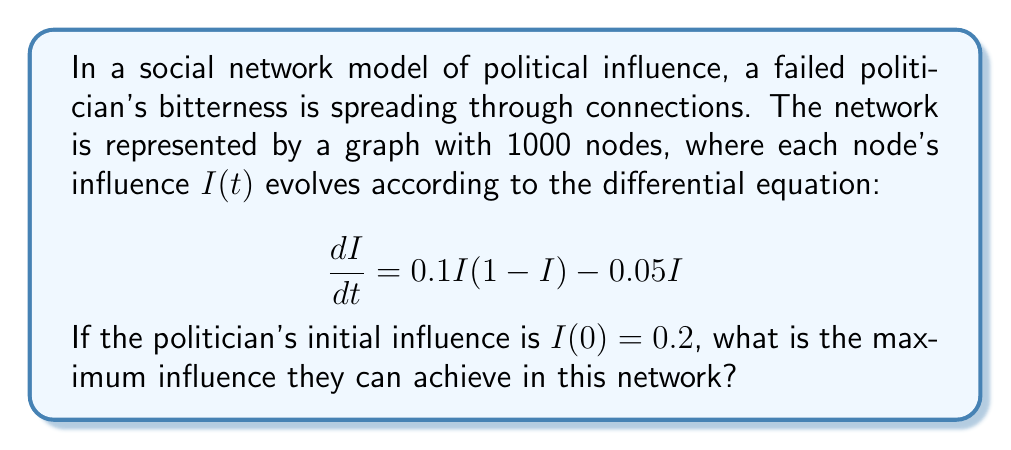What is the answer to this math problem? 1) The given differential equation is a modified logistic growth model:

   $$\frac{dI}{dt} = 0.1I(1-I) - 0.05I$$

2) To find the equilibrium points, set $\frac{dI}{dt} = 0$:

   $$0 = 0.1I(1-I) - 0.05I$$
   $$0 = I(0.1 - 0.1I - 0.05)$$
   $$0 = I(0.05 - 0.1I)$$

3) Solve for I:
   $I = 0$ or $0.05 - 0.1I = 0$
   $I = 0$ or $I = 0.5$

4) The non-zero equilibrium point $I = 0.5$ represents the maximum influence achievable.

5) To verify stability, we can check the derivative of $\frac{dI}{dt}$ with respect to $I$:

   $$\frac{d}{dI}(\frac{dI}{dt}) = 0.1(1-2I) - 0.05$$

6) At $I = 0.5$:
   
   $$0.1(1-2(0.5)) - 0.05 = -0.05$$

   The negative value indicates this is a stable equilibrium point.

Therefore, regardless of the initial condition (as long as it's non-zero), the influence will approach 0.5 as t approaches infinity.
Answer: 0.5 